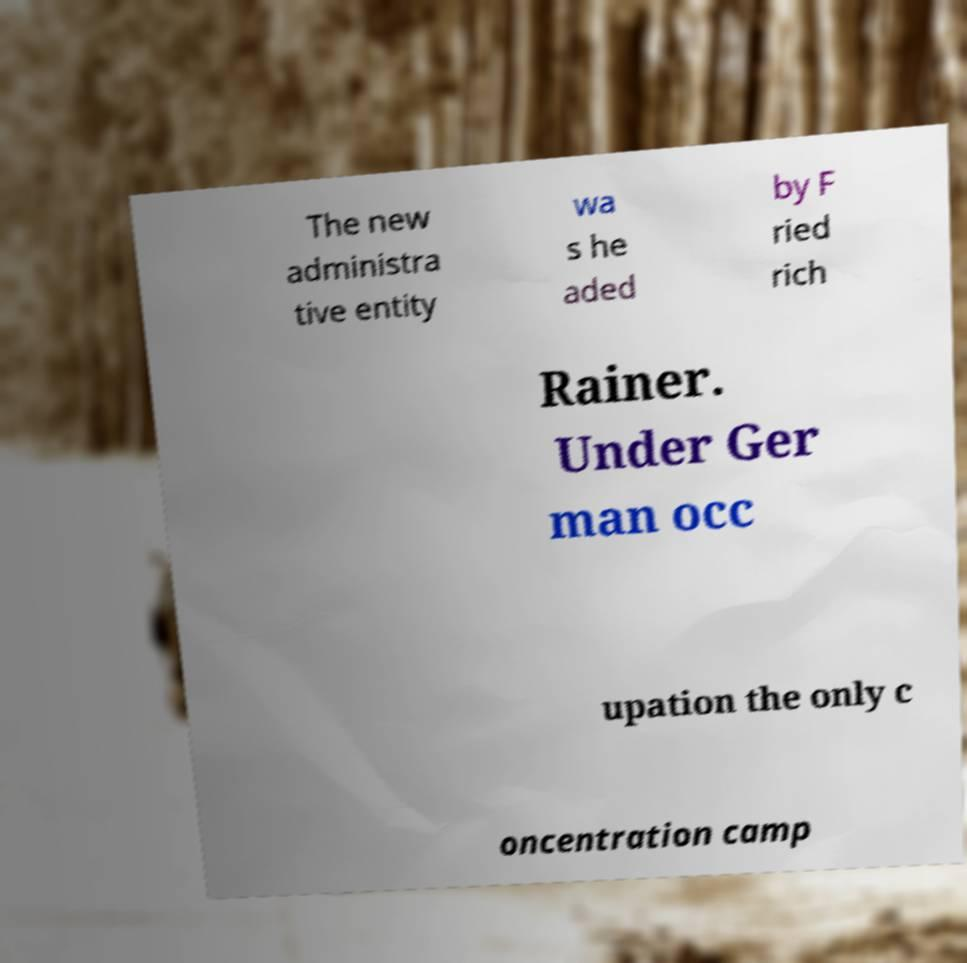Could you extract and type out the text from this image? The new administra tive entity wa s he aded by F ried rich Rainer. Under Ger man occ upation the only c oncentration camp 